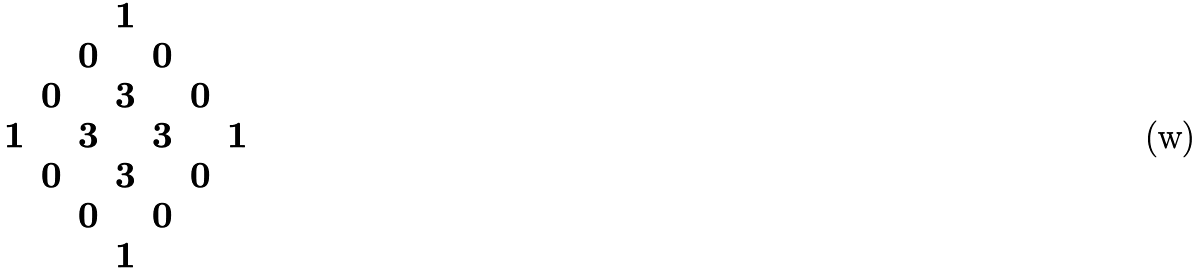<formula> <loc_0><loc_0><loc_500><loc_500>\begin{array} { c c c c c c c } & & & 1 & & & \\ & & 0 & & 0 & & \\ & 0 & & 3 & & 0 & \\ 1 & & 3 & & 3 & & 1 \\ & 0 & & 3 & & 0 & \\ & & 0 & & 0 & & \\ & & & 1 & & & \end{array}</formula> 